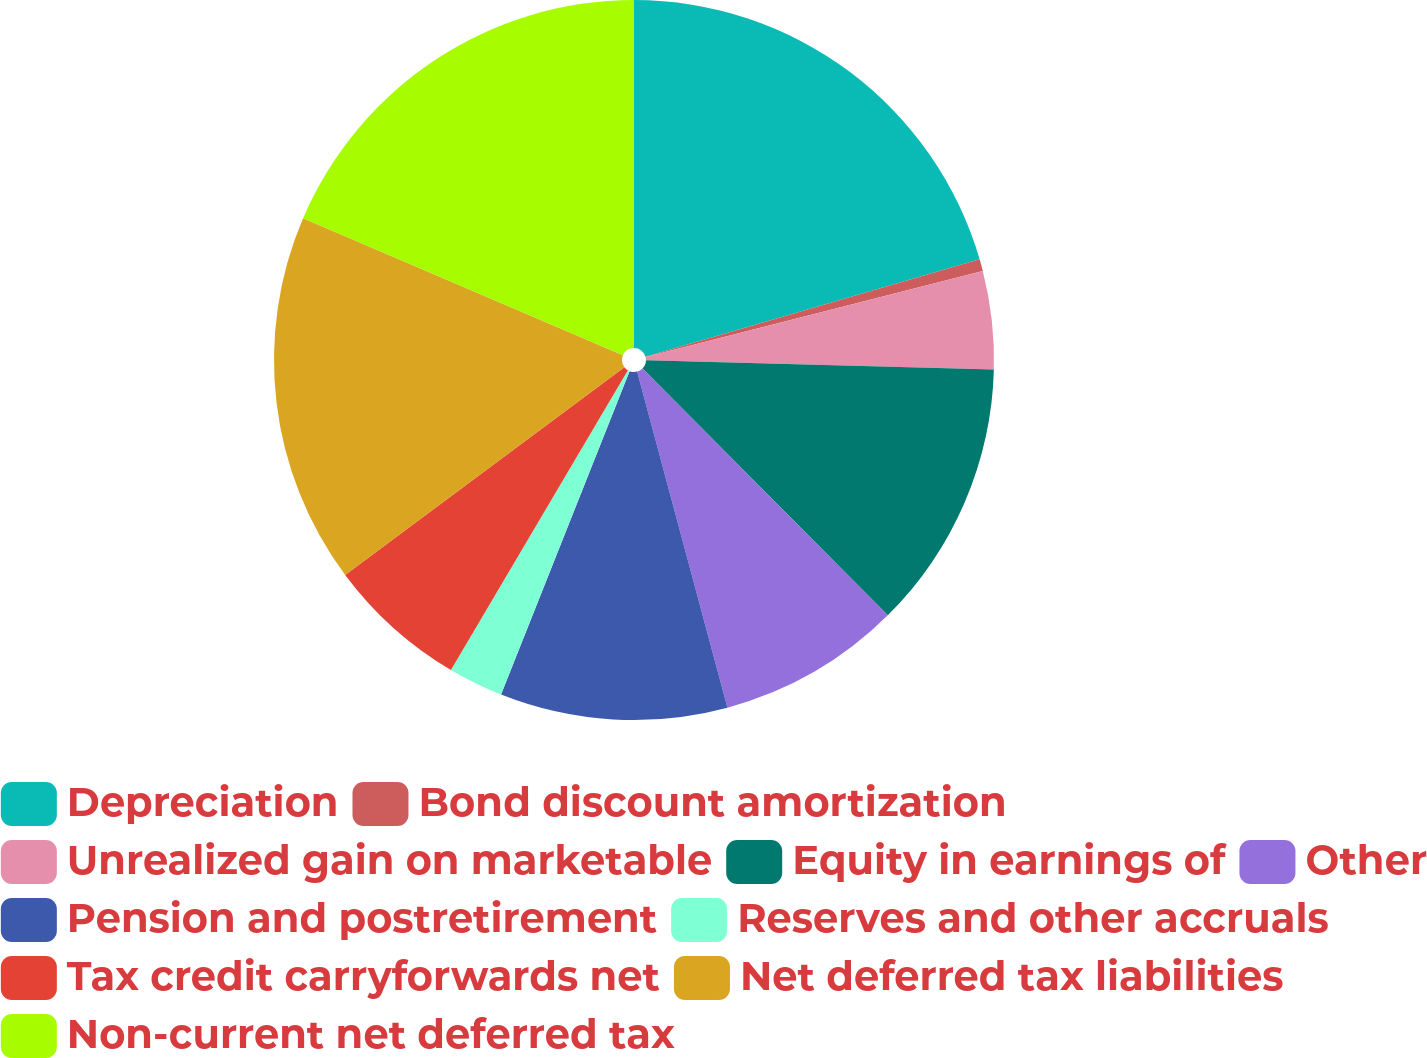<chart> <loc_0><loc_0><loc_500><loc_500><pie_chart><fcel>Depreciation<fcel>Bond discount amortization<fcel>Unrealized gain on marketable<fcel>Equity in earnings of<fcel>Other<fcel>Pension and postretirement<fcel>Reserves and other accruals<fcel>Tax credit carryforwards net<fcel>Net deferred tax liabilities<fcel>Non-current net deferred tax<nl><fcel>20.49%<fcel>0.53%<fcel>4.4%<fcel>12.13%<fcel>8.27%<fcel>10.2%<fcel>2.47%<fcel>6.33%<fcel>16.62%<fcel>18.56%<nl></chart> 